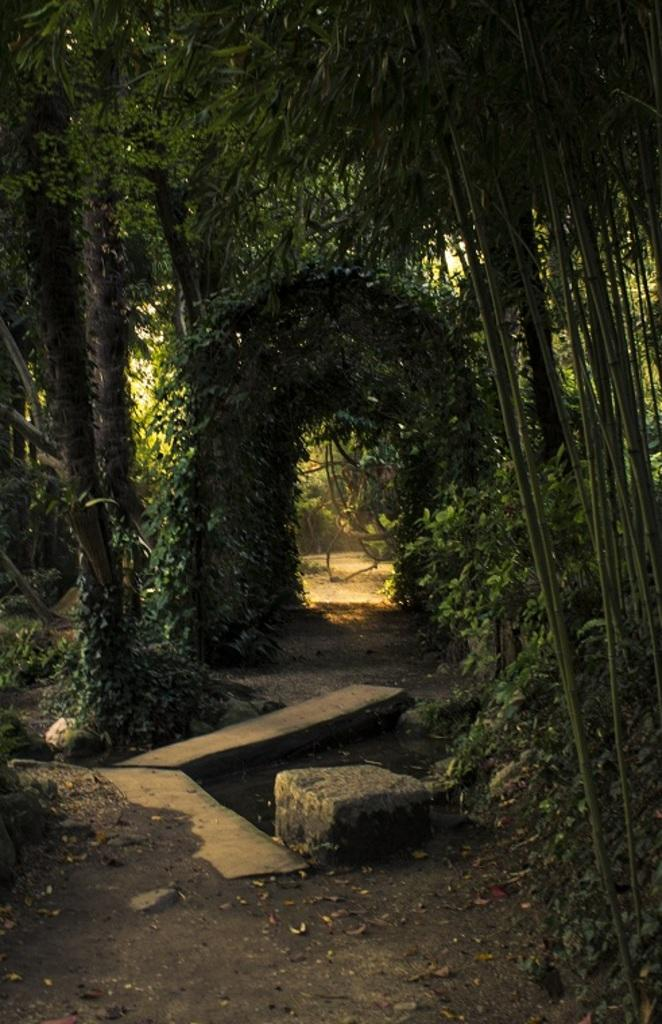What can be inferred about the location of the image? The image is likely clicked outside. What is the main feature in the middle of the image? There is a path in the middle of the image. What can be seen alongside the path? There are rocks along the path. What type of vegetation is visible in the background of the image? There are many trees in the background of the image. What type of clouds can be seen in the image? There are no clouds visible in the image. What form does the cream take in the image? There is no cream present in the image. 